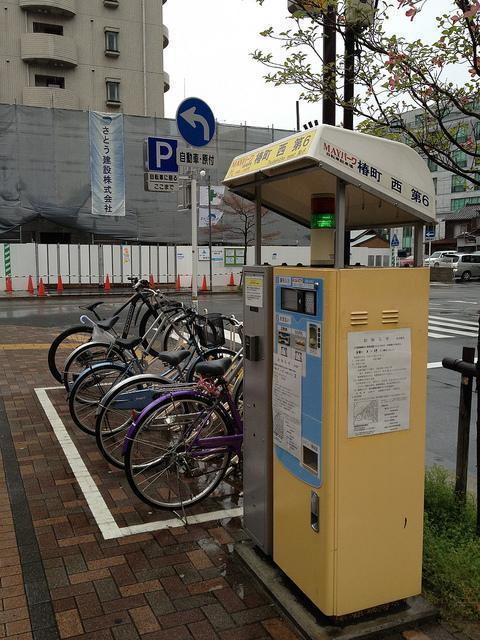How many bicycles are there?
Give a very brief answer. 5. How many bicycles can you see?
Give a very brief answer. 5. 